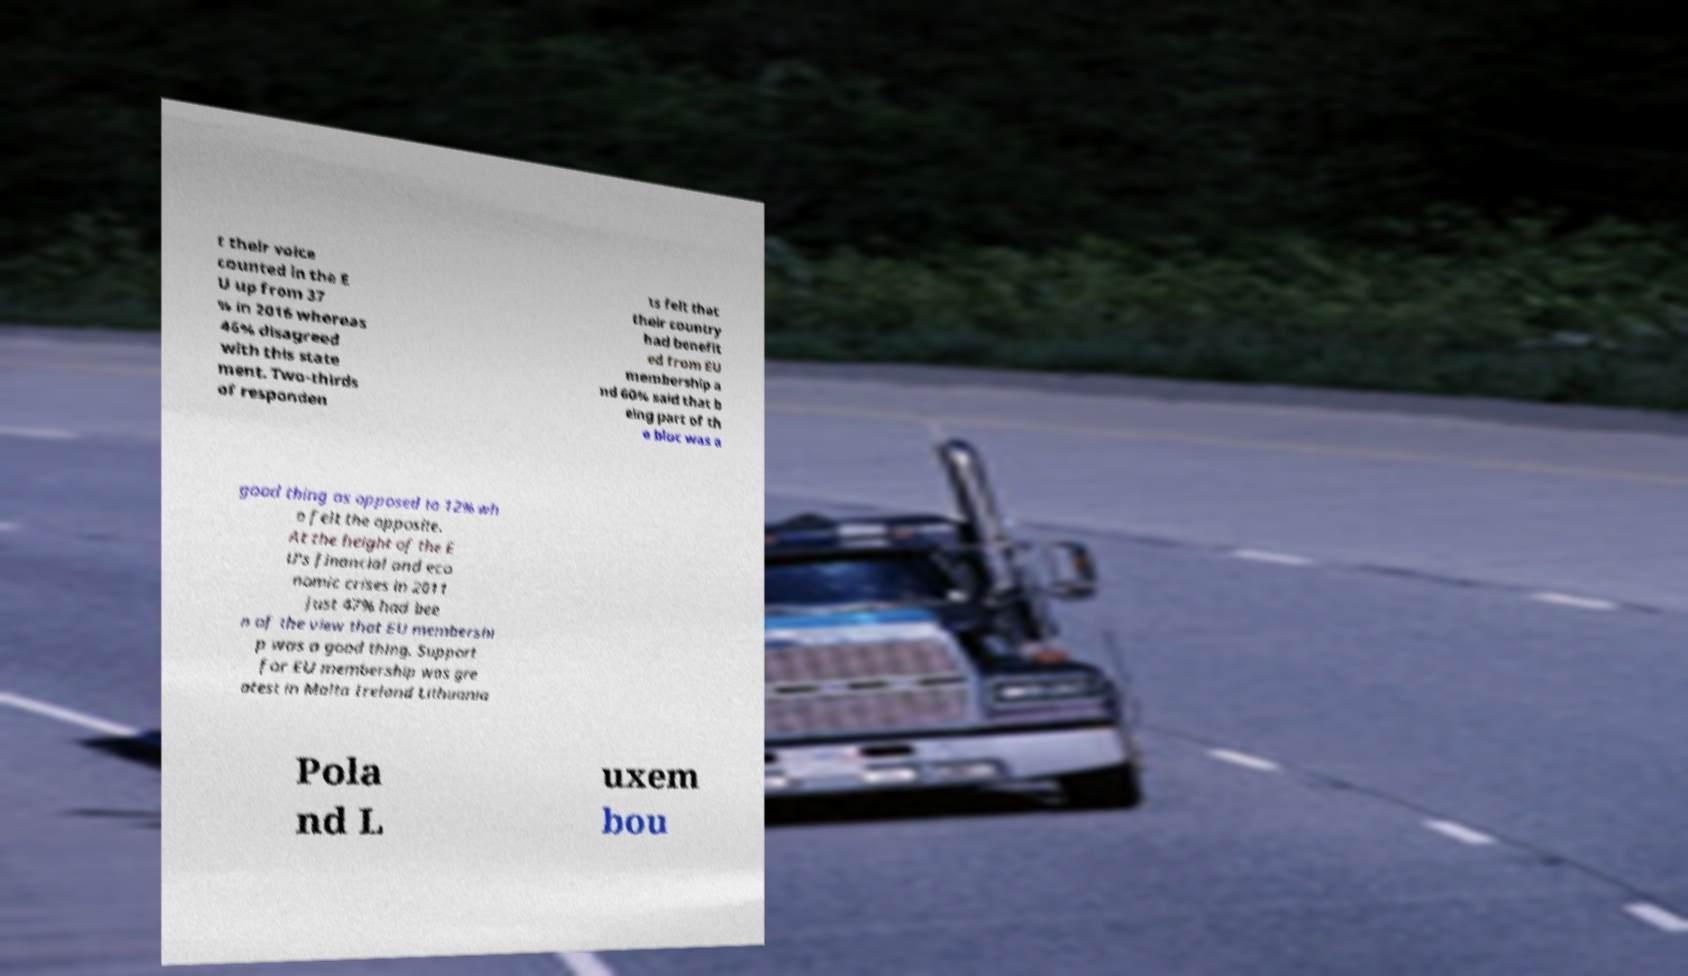Could you assist in decoding the text presented in this image and type it out clearly? t their voice counted in the E U up from 37 % in 2016 whereas 46% disagreed with this state ment. Two-thirds of responden ts felt that their country had benefit ed from EU membership a nd 60% said that b eing part of th e bloc was a good thing as opposed to 12% wh o felt the opposite. At the height of the E U's financial and eco nomic crises in 2011 just 47% had bee n of the view that EU membershi p was a good thing. Support for EU membership was gre atest in Malta Ireland Lithuania Pola nd L uxem bou 